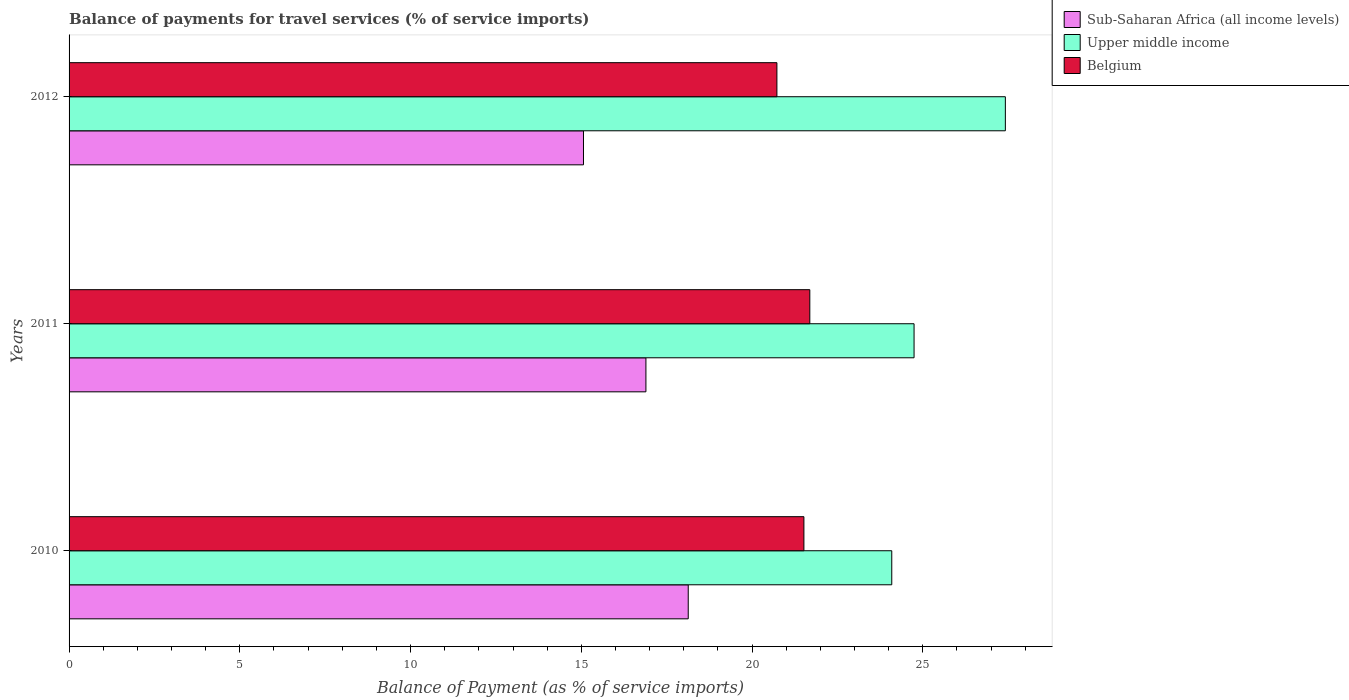How many different coloured bars are there?
Offer a terse response. 3. How many groups of bars are there?
Keep it short and to the point. 3. Are the number of bars per tick equal to the number of legend labels?
Your response must be concise. Yes. How many bars are there on the 3rd tick from the bottom?
Provide a short and direct response. 3. What is the label of the 3rd group of bars from the top?
Offer a very short reply. 2010. What is the balance of payments for travel services in Belgium in 2010?
Provide a short and direct response. 21.52. Across all years, what is the maximum balance of payments for travel services in Upper middle income?
Provide a short and direct response. 27.42. Across all years, what is the minimum balance of payments for travel services in Upper middle income?
Make the answer very short. 24.09. In which year was the balance of payments for travel services in Upper middle income minimum?
Keep it short and to the point. 2010. What is the total balance of payments for travel services in Sub-Saharan Africa (all income levels) in the graph?
Keep it short and to the point. 50.09. What is the difference between the balance of payments for travel services in Sub-Saharan Africa (all income levels) in 2010 and that in 2011?
Provide a succinct answer. 1.24. What is the difference between the balance of payments for travel services in Sub-Saharan Africa (all income levels) in 2010 and the balance of payments for travel services in Upper middle income in 2011?
Offer a terse response. -6.61. What is the average balance of payments for travel services in Upper middle income per year?
Your response must be concise. 25.42. In the year 2011, what is the difference between the balance of payments for travel services in Upper middle income and balance of payments for travel services in Belgium?
Give a very brief answer. 3.05. In how many years, is the balance of payments for travel services in Upper middle income greater than 9 %?
Your response must be concise. 3. What is the ratio of the balance of payments for travel services in Upper middle income in 2010 to that in 2011?
Keep it short and to the point. 0.97. Is the difference between the balance of payments for travel services in Upper middle income in 2010 and 2011 greater than the difference between the balance of payments for travel services in Belgium in 2010 and 2011?
Keep it short and to the point. No. What is the difference between the highest and the second highest balance of payments for travel services in Belgium?
Offer a terse response. 0.17. What is the difference between the highest and the lowest balance of payments for travel services in Sub-Saharan Africa (all income levels)?
Your response must be concise. 3.07. In how many years, is the balance of payments for travel services in Upper middle income greater than the average balance of payments for travel services in Upper middle income taken over all years?
Offer a very short reply. 1. What does the 3rd bar from the top in 2011 represents?
Ensure brevity in your answer.  Sub-Saharan Africa (all income levels). What does the 2nd bar from the bottom in 2010 represents?
Make the answer very short. Upper middle income. Is it the case that in every year, the sum of the balance of payments for travel services in Upper middle income and balance of payments for travel services in Sub-Saharan Africa (all income levels) is greater than the balance of payments for travel services in Belgium?
Give a very brief answer. Yes. How many bars are there?
Your answer should be very brief. 9. How many years are there in the graph?
Offer a very short reply. 3. Are the values on the major ticks of X-axis written in scientific E-notation?
Your answer should be compact. No. Does the graph contain any zero values?
Give a very brief answer. No. Does the graph contain grids?
Make the answer very short. No. Where does the legend appear in the graph?
Your answer should be very brief. Top right. How are the legend labels stacked?
Keep it short and to the point. Vertical. What is the title of the graph?
Ensure brevity in your answer.  Balance of payments for travel services (% of service imports). Does "Uzbekistan" appear as one of the legend labels in the graph?
Give a very brief answer. No. What is the label or title of the X-axis?
Ensure brevity in your answer.  Balance of Payment (as % of service imports). What is the label or title of the Y-axis?
Provide a short and direct response. Years. What is the Balance of Payment (as % of service imports) of Sub-Saharan Africa (all income levels) in 2010?
Your answer should be very brief. 18.13. What is the Balance of Payment (as % of service imports) of Upper middle income in 2010?
Provide a short and direct response. 24.09. What is the Balance of Payment (as % of service imports) in Belgium in 2010?
Provide a succinct answer. 21.52. What is the Balance of Payment (as % of service imports) of Sub-Saharan Africa (all income levels) in 2011?
Your answer should be compact. 16.89. What is the Balance of Payment (as % of service imports) of Upper middle income in 2011?
Provide a short and direct response. 24.74. What is the Balance of Payment (as % of service imports) of Belgium in 2011?
Your answer should be compact. 21.69. What is the Balance of Payment (as % of service imports) in Sub-Saharan Africa (all income levels) in 2012?
Your response must be concise. 15.06. What is the Balance of Payment (as % of service imports) of Upper middle income in 2012?
Ensure brevity in your answer.  27.42. What is the Balance of Payment (as % of service imports) of Belgium in 2012?
Your response must be concise. 20.73. Across all years, what is the maximum Balance of Payment (as % of service imports) of Sub-Saharan Africa (all income levels)?
Your response must be concise. 18.13. Across all years, what is the maximum Balance of Payment (as % of service imports) in Upper middle income?
Your answer should be very brief. 27.42. Across all years, what is the maximum Balance of Payment (as % of service imports) of Belgium?
Ensure brevity in your answer.  21.69. Across all years, what is the minimum Balance of Payment (as % of service imports) in Sub-Saharan Africa (all income levels)?
Ensure brevity in your answer.  15.06. Across all years, what is the minimum Balance of Payment (as % of service imports) in Upper middle income?
Give a very brief answer. 24.09. Across all years, what is the minimum Balance of Payment (as % of service imports) of Belgium?
Offer a terse response. 20.73. What is the total Balance of Payment (as % of service imports) in Sub-Saharan Africa (all income levels) in the graph?
Provide a succinct answer. 50.09. What is the total Balance of Payment (as % of service imports) in Upper middle income in the graph?
Give a very brief answer. 76.25. What is the total Balance of Payment (as % of service imports) in Belgium in the graph?
Offer a terse response. 63.94. What is the difference between the Balance of Payment (as % of service imports) in Sub-Saharan Africa (all income levels) in 2010 and that in 2011?
Your answer should be compact. 1.24. What is the difference between the Balance of Payment (as % of service imports) in Upper middle income in 2010 and that in 2011?
Give a very brief answer. -0.65. What is the difference between the Balance of Payment (as % of service imports) in Belgium in 2010 and that in 2011?
Ensure brevity in your answer.  -0.17. What is the difference between the Balance of Payment (as % of service imports) in Sub-Saharan Africa (all income levels) in 2010 and that in 2012?
Ensure brevity in your answer.  3.07. What is the difference between the Balance of Payment (as % of service imports) of Upper middle income in 2010 and that in 2012?
Ensure brevity in your answer.  -3.33. What is the difference between the Balance of Payment (as % of service imports) of Belgium in 2010 and that in 2012?
Give a very brief answer. 0.79. What is the difference between the Balance of Payment (as % of service imports) in Sub-Saharan Africa (all income levels) in 2011 and that in 2012?
Provide a short and direct response. 1.83. What is the difference between the Balance of Payment (as % of service imports) in Upper middle income in 2011 and that in 2012?
Keep it short and to the point. -2.67. What is the difference between the Balance of Payment (as % of service imports) in Belgium in 2011 and that in 2012?
Offer a very short reply. 0.96. What is the difference between the Balance of Payment (as % of service imports) in Sub-Saharan Africa (all income levels) in 2010 and the Balance of Payment (as % of service imports) in Upper middle income in 2011?
Offer a terse response. -6.61. What is the difference between the Balance of Payment (as % of service imports) of Sub-Saharan Africa (all income levels) in 2010 and the Balance of Payment (as % of service imports) of Belgium in 2011?
Ensure brevity in your answer.  -3.56. What is the difference between the Balance of Payment (as % of service imports) in Upper middle income in 2010 and the Balance of Payment (as % of service imports) in Belgium in 2011?
Offer a terse response. 2.4. What is the difference between the Balance of Payment (as % of service imports) in Sub-Saharan Africa (all income levels) in 2010 and the Balance of Payment (as % of service imports) in Upper middle income in 2012?
Offer a terse response. -9.29. What is the difference between the Balance of Payment (as % of service imports) of Sub-Saharan Africa (all income levels) in 2010 and the Balance of Payment (as % of service imports) of Belgium in 2012?
Your response must be concise. -2.6. What is the difference between the Balance of Payment (as % of service imports) in Upper middle income in 2010 and the Balance of Payment (as % of service imports) in Belgium in 2012?
Give a very brief answer. 3.36. What is the difference between the Balance of Payment (as % of service imports) in Sub-Saharan Africa (all income levels) in 2011 and the Balance of Payment (as % of service imports) in Upper middle income in 2012?
Provide a short and direct response. -10.53. What is the difference between the Balance of Payment (as % of service imports) in Sub-Saharan Africa (all income levels) in 2011 and the Balance of Payment (as % of service imports) in Belgium in 2012?
Offer a terse response. -3.84. What is the difference between the Balance of Payment (as % of service imports) of Upper middle income in 2011 and the Balance of Payment (as % of service imports) of Belgium in 2012?
Your answer should be compact. 4.02. What is the average Balance of Payment (as % of service imports) of Sub-Saharan Africa (all income levels) per year?
Give a very brief answer. 16.7. What is the average Balance of Payment (as % of service imports) of Upper middle income per year?
Give a very brief answer. 25.42. What is the average Balance of Payment (as % of service imports) of Belgium per year?
Your answer should be very brief. 21.31. In the year 2010, what is the difference between the Balance of Payment (as % of service imports) in Sub-Saharan Africa (all income levels) and Balance of Payment (as % of service imports) in Upper middle income?
Your answer should be compact. -5.96. In the year 2010, what is the difference between the Balance of Payment (as % of service imports) in Sub-Saharan Africa (all income levels) and Balance of Payment (as % of service imports) in Belgium?
Make the answer very short. -3.39. In the year 2010, what is the difference between the Balance of Payment (as % of service imports) in Upper middle income and Balance of Payment (as % of service imports) in Belgium?
Provide a succinct answer. 2.57. In the year 2011, what is the difference between the Balance of Payment (as % of service imports) in Sub-Saharan Africa (all income levels) and Balance of Payment (as % of service imports) in Upper middle income?
Keep it short and to the point. -7.85. In the year 2011, what is the difference between the Balance of Payment (as % of service imports) of Sub-Saharan Africa (all income levels) and Balance of Payment (as % of service imports) of Belgium?
Provide a short and direct response. -4.8. In the year 2011, what is the difference between the Balance of Payment (as % of service imports) of Upper middle income and Balance of Payment (as % of service imports) of Belgium?
Provide a short and direct response. 3.05. In the year 2012, what is the difference between the Balance of Payment (as % of service imports) in Sub-Saharan Africa (all income levels) and Balance of Payment (as % of service imports) in Upper middle income?
Make the answer very short. -12.35. In the year 2012, what is the difference between the Balance of Payment (as % of service imports) of Sub-Saharan Africa (all income levels) and Balance of Payment (as % of service imports) of Belgium?
Your response must be concise. -5.66. In the year 2012, what is the difference between the Balance of Payment (as % of service imports) of Upper middle income and Balance of Payment (as % of service imports) of Belgium?
Offer a very short reply. 6.69. What is the ratio of the Balance of Payment (as % of service imports) in Sub-Saharan Africa (all income levels) in 2010 to that in 2011?
Ensure brevity in your answer.  1.07. What is the ratio of the Balance of Payment (as % of service imports) in Upper middle income in 2010 to that in 2011?
Your response must be concise. 0.97. What is the ratio of the Balance of Payment (as % of service imports) of Belgium in 2010 to that in 2011?
Your answer should be compact. 0.99. What is the ratio of the Balance of Payment (as % of service imports) of Sub-Saharan Africa (all income levels) in 2010 to that in 2012?
Offer a terse response. 1.2. What is the ratio of the Balance of Payment (as % of service imports) of Upper middle income in 2010 to that in 2012?
Give a very brief answer. 0.88. What is the ratio of the Balance of Payment (as % of service imports) of Belgium in 2010 to that in 2012?
Provide a short and direct response. 1.04. What is the ratio of the Balance of Payment (as % of service imports) of Sub-Saharan Africa (all income levels) in 2011 to that in 2012?
Give a very brief answer. 1.12. What is the ratio of the Balance of Payment (as % of service imports) of Upper middle income in 2011 to that in 2012?
Provide a short and direct response. 0.9. What is the ratio of the Balance of Payment (as % of service imports) in Belgium in 2011 to that in 2012?
Offer a very short reply. 1.05. What is the difference between the highest and the second highest Balance of Payment (as % of service imports) in Sub-Saharan Africa (all income levels)?
Your answer should be compact. 1.24. What is the difference between the highest and the second highest Balance of Payment (as % of service imports) in Upper middle income?
Make the answer very short. 2.67. What is the difference between the highest and the second highest Balance of Payment (as % of service imports) in Belgium?
Your answer should be very brief. 0.17. What is the difference between the highest and the lowest Balance of Payment (as % of service imports) in Sub-Saharan Africa (all income levels)?
Provide a succinct answer. 3.07. What is the difference between the highest and the lowest Balance of Payment (as % of service imports) of Upper middle income?
Offer a terse response. 3.33. What is the difference between the highest and the lowest Balance of Payment (as % of service imports) of Belgium?
Offer a very short reply. 0.96. 